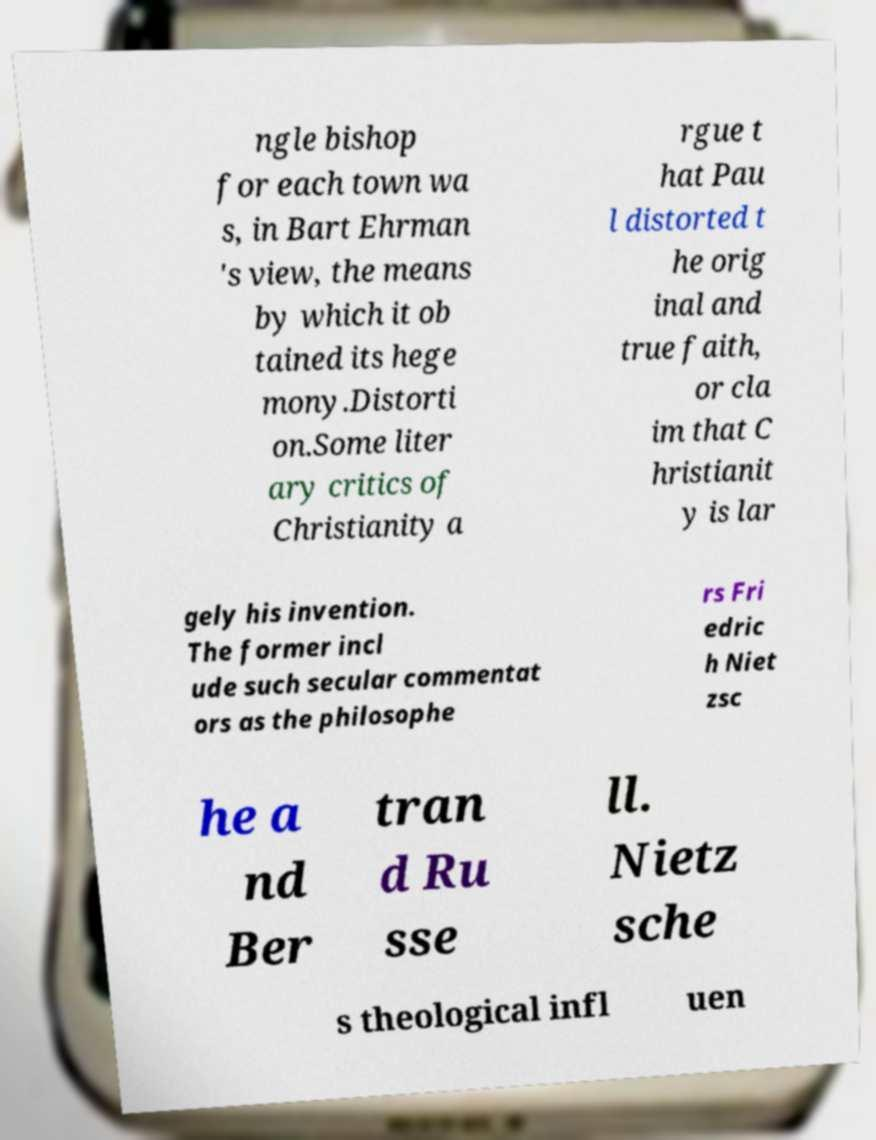Can you read and provide the text displayed in the image?This photo seems to have some interesting text. Can you extract and type it out for me? ngle bishop for each town wa s, in Bart Ehrman 's view, the means by which it ob tained its hege mony.Distorti on.Some liter ary critics of Christianity a rgue t hat Pau l distorted t he orig inal and true faith, or cla im that C hristianit y is lar gely his invention. The former incl ude such secular commentat ors as the philosophe rs Fri edric h Niet zsc he a nd Ber tran d Ru sse ll. Nietz sche s theological infl uen 